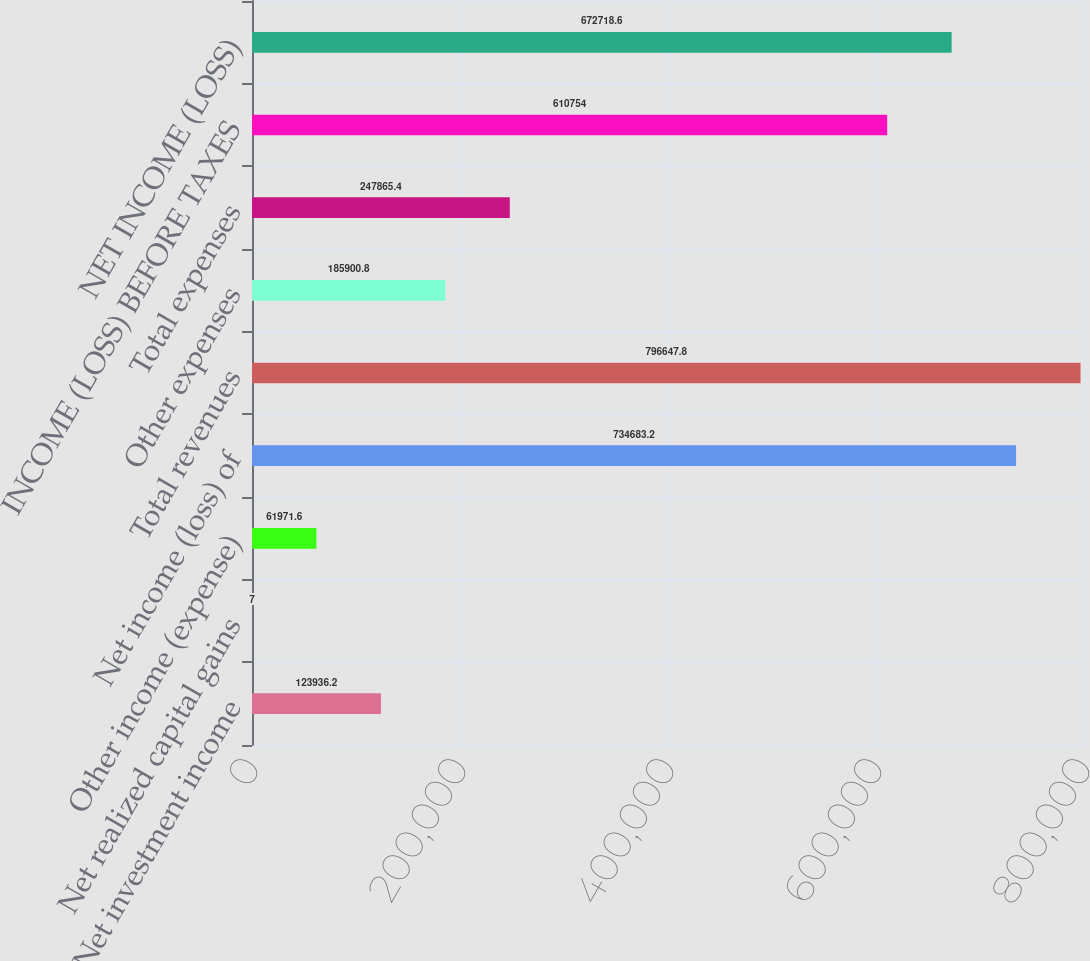<chart> <loc_0><loc_0><loc_500><loc_500><bar_chart><fcel>Net investment income<fcel>Net realized capital gains<fcel>Other income (expense)<fcel>Net income (loss) of<fcel>Total revenues<fcel>Other expenses<fcel>Total expenses<fcel>INCOME (LOSS) BEFORE TAXES<fcel>NET INCOME (LOSS)<nl><fcel>123936<fcel>7<fcel>61971.6<fcel>734683<fcel>796648<fcel>185901<fcel>247865<fcel>610754<fcel>672719<nl></chart> 